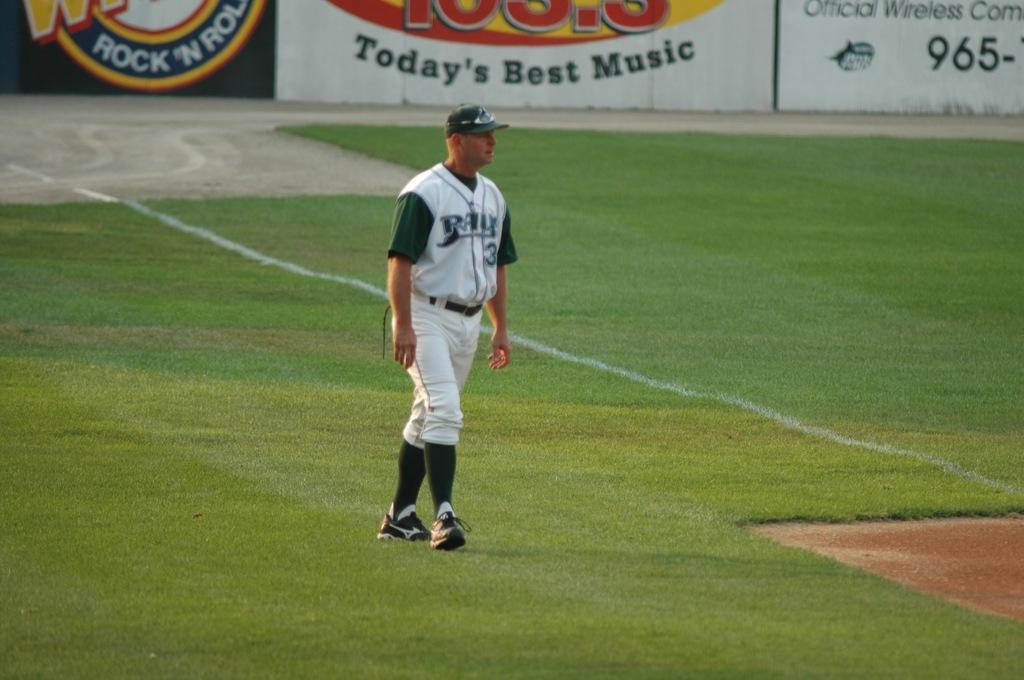<image>
Offer a succinct explanation of the picture presented. A baseball player stands in a field that is supported by a radio station with Today's best music 